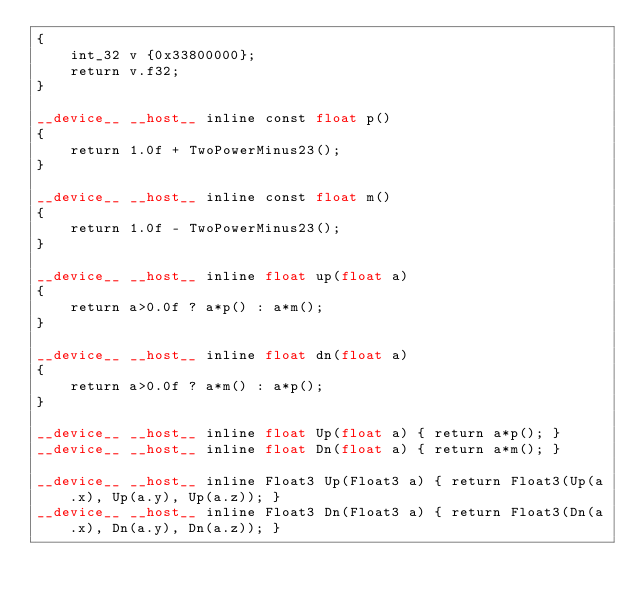<code> <loc_0><loc_0><loc_500><loc_500><_Cuda_>{
	int_32 v {0x33800000};
	return v.f32;
}

__device__ __host__ inline const float p()
{
	return 1.0f + TwoPowerMinus23();
}

__device__ __host__ inline const float m()
{
	return 1.0f - TwoPowerMinus23();
}

__device__ __host__ inline float up(float a)
{
	return a>0.0f ? a*p() : a*m();
}

__device__ __host__ inline float dn(float a)
{
	return a>0.0f ? a*m() : a*p();
}

__device__ __host__ inline float Up(float a) { return a*p(); }
__device__ __host__ inline float Dn(float a) { return a*m(); }

__device__ __host__ inline Float3 Up(Float3 a) { return Float3(Up(a.x), Up(a.y), Up(a.z)); }
__device__ __host__ inline Float3 Dn(Float3 a) { return Float3(Dn(a.x), Dn(a.y), Dn(a.z)); }
</code> 